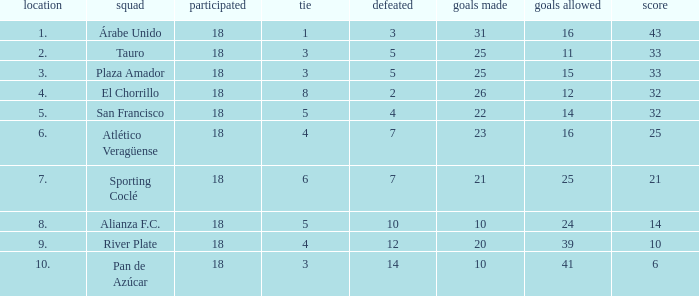How many points did the team have that conceded 41 goals and finish in a place larger than 10? 0.0. 